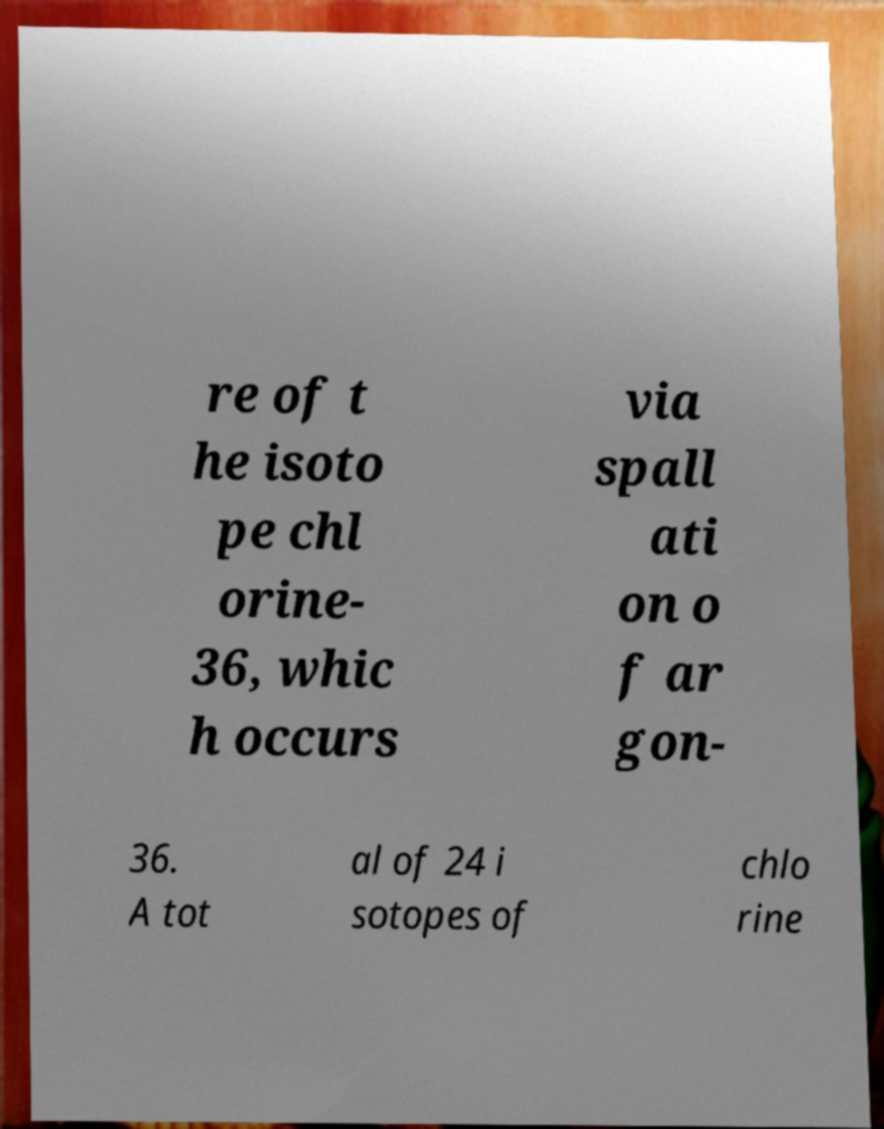Can you read and provide the text displayed in the image?This photo seems to have some interesting text. Can you extract and type it out for me? re of t he isoto pe chl orine- 36, whic h occurs via spall ati on o f ar gon- 36. A tot al of 24 i sotopes of chlo rine 